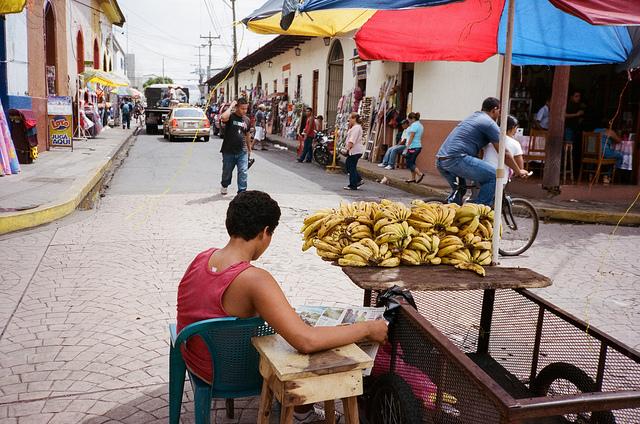What fruit is on the table?
Quick response, please. Bananas. How many men are wearing red tanks?
Concise answer only. 1. What is keeping the bananas shaded?
Be succinct. Umbrella. 